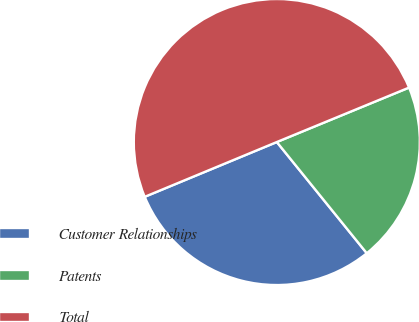Convert chart. <chart><loc_0><loc_0><loc_500><loc_500><pie_chart><fcel>Customer Relationships<fcel>Patents<fcel>Total<nl><fcel>29.57%<fcel>20.39%<fcel>50.04%<nl></chart> 